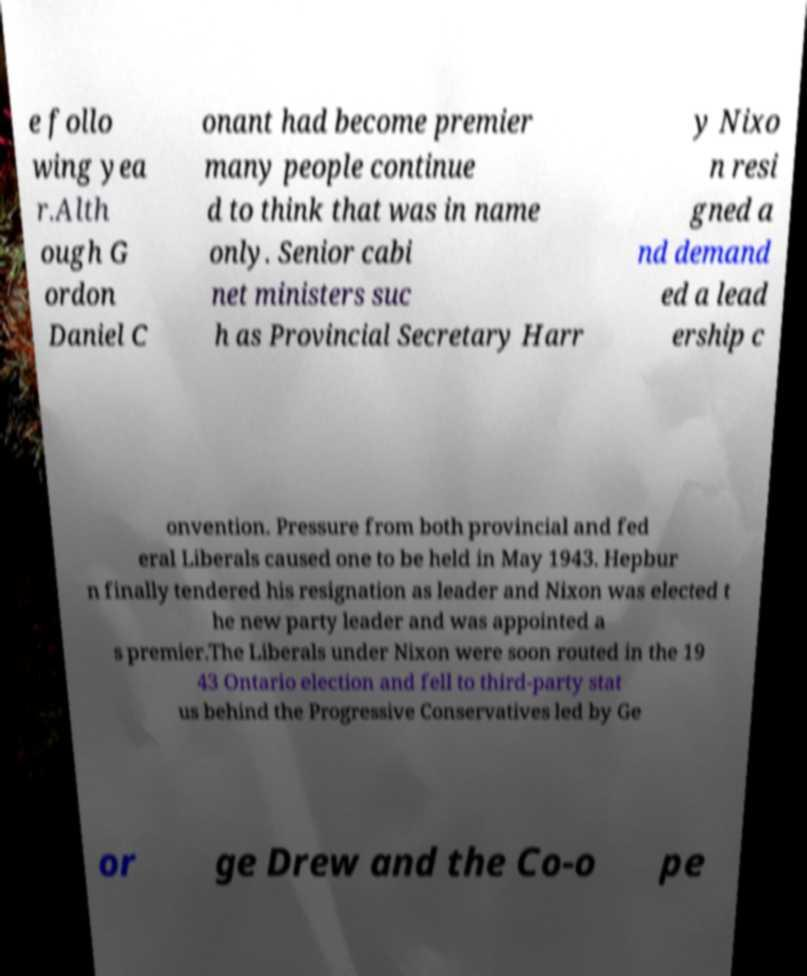Can you read and provide the text displayed in the image?This photo seems to have some interesting text. Can you extract and type it out for me? e follo wing yea r.Alth ough G ordon Daniel C onant had become premier many people continue d to think that was in name only. Senior cabi net ministers suc h as Provincial Secretary Harr y Nixo n resi gned a nd demand ed a lead ership c onvention. Pressure from both provincial and fed eral Liberals caused one to be held in May 1943. Hepbur n finally tendered his resignation as leader and Nixon was elected t he new party leader and was appointed a s premier.The Liberals under Nixon were soon routed in the 19 43 Ontario election and fell to third-party stat us behind the Progressive Conservatives led by Ge or ge Drew and the Co-o pe 